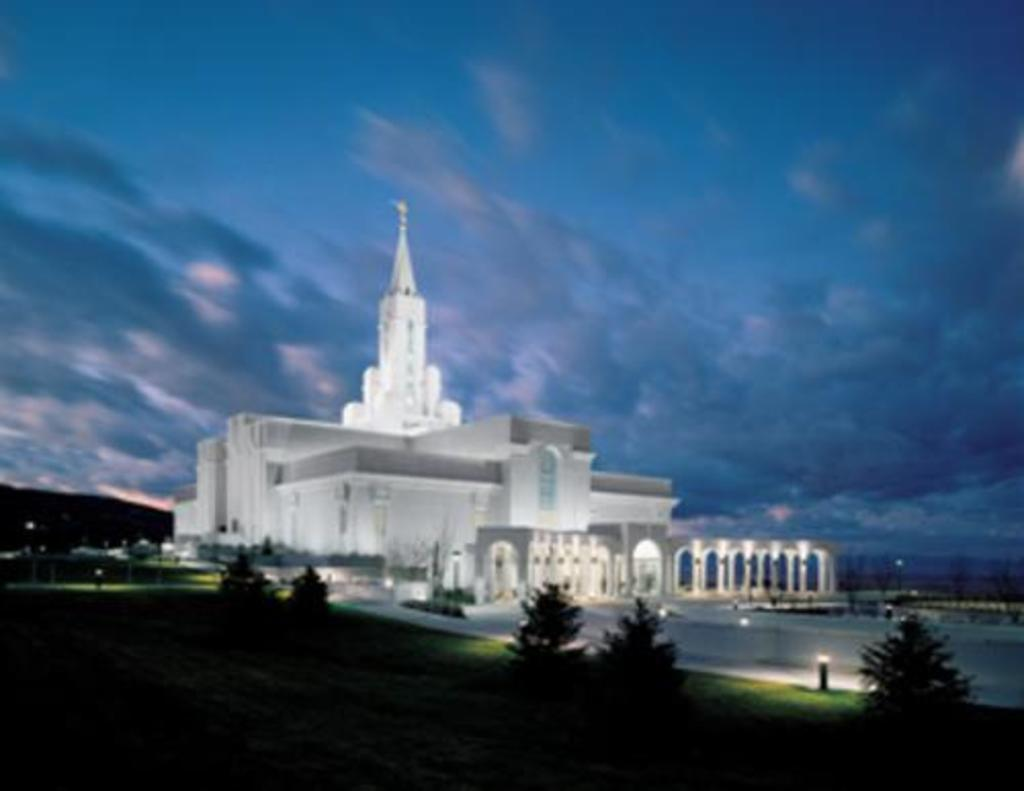What type of structure is in the image? There is a white building in the image. What can be seen on the left side of the building? There are trees and lights on the left side of the building. What is visible behind the building? The sky is visible behind the building. What type of cemetery can be seen on the right side of the building? There is no cemetery present on the right side of the building in the image. 